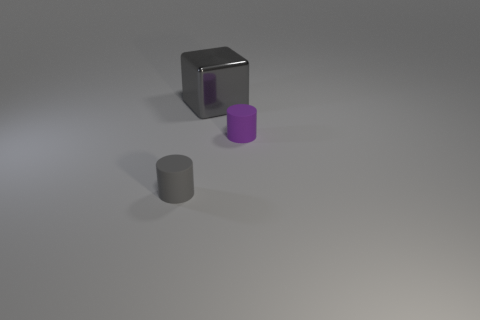Is there anything else that has the same material as the large gray cube?
Provide a succinct answer. No. Is the number of purple matte cylinders on the left side of the shiny object the same as the number of cylinders?
Your response must be concise. No. How many large metal blocks have the same color as the big thing?
Provide a short and direct response. 0. What color is the other tiny matte thing that is the same shape as the tiny gray matte thing?
Provide a short and direct response. Purple. Do the cube and the gray cylinder have the same size?
Keep it short and to the point. No. Are there an equal number of big metallic objects on the left side of the big metal thing and big shiny things that are on the right side of the tiny purple matte cylinder?
Offer a terse response. Yes. Is there a brown cylinder?
Provide a short and direct response. No. What is the size of the gray matte object that is the same shape as the tiny purple rubber object?
Offer a very short reply. Small. There is a thing in front of the tiny purple object; what is its size?
Your answer should be very brief. Small. Is the number of big things that are to the right of the tiny purple matte cylinder greater than the number of green cylinders?
Make the answer very short. No. 